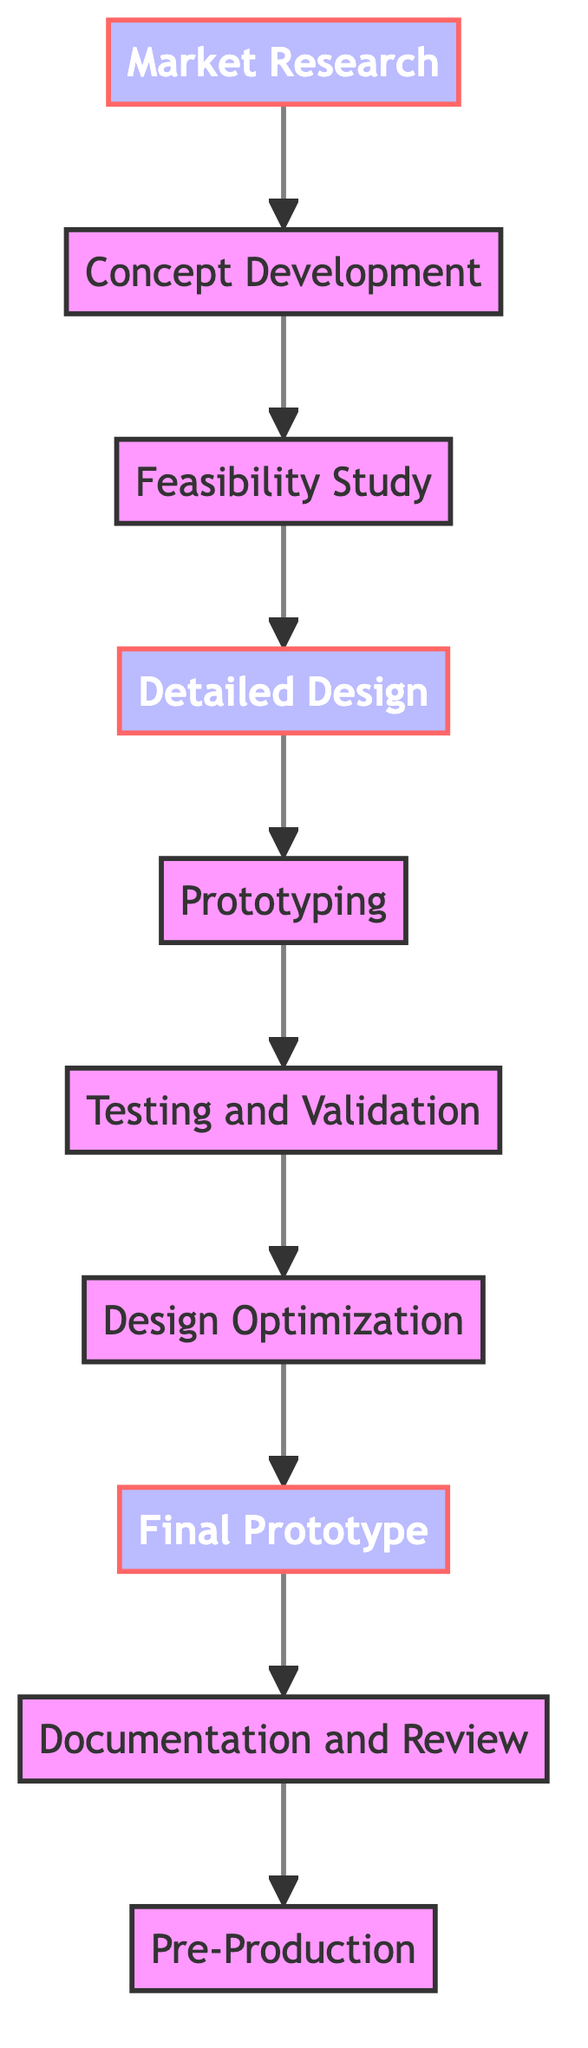What is the first step in the design process? The diagram indicates that the first step is "Market Research". This is identified as the starting node at the top of the flowchart.
Answer: Market Research How many total steps are described in the diagram? By counting each individual node from "Market Research" to "Pre-Production", there are ten distinct steps represented in the flowchart.
Answer: Ten Which step comes after "Detailed Design"? The flowchart shows that "Prototyping" follows "Detailed Design". This can be inferred by following the arrow from "Detailed Design" down to the next step.
Answer: Prototyping What phase is "Final Prototype" classified as? The node labeled "Final Prototype" is highlighted in a different color and is classified as a phase in the flowchart, indicating it is an important milestone in the design process.
Answer: Phase Which two steps are directly connected by an arrow? By examining the flowchart, "Prototyping" and "Testing and Validation" are directly connected by an arrow, indicating a direct transition from one to the other.
Answer: Prototyping and Testing and Validation What is the last step in the design process? The diagram illustrates that the last step is "Pre-Production", which is the final node in the flowchart.
Answer: Pre-Production Which step involves evaluating technical feasibility? The step that involves evaluating technical feasibility is "Feasibility Study". This can be determined by looking for the description associated with that node, which explicitly mentions feasibility evaluation.
Answer: Feasibility Study How many phases are identified in the flowchart? By identifying nodes that are classified as phases, there are five phases indicated in the flowchart: "Market Research", "Detailed Design", "Final Prototype", "Testing and Validation", and "Pre-Production".
Answer: Five Which phase involves optimizing design specifications? The phase that involves optimizing design specifications is "Design Optimization". This is recognized by following the flow from "Testing and Validation" to see which step is focused on optimization.
Answer: Design Optimization 